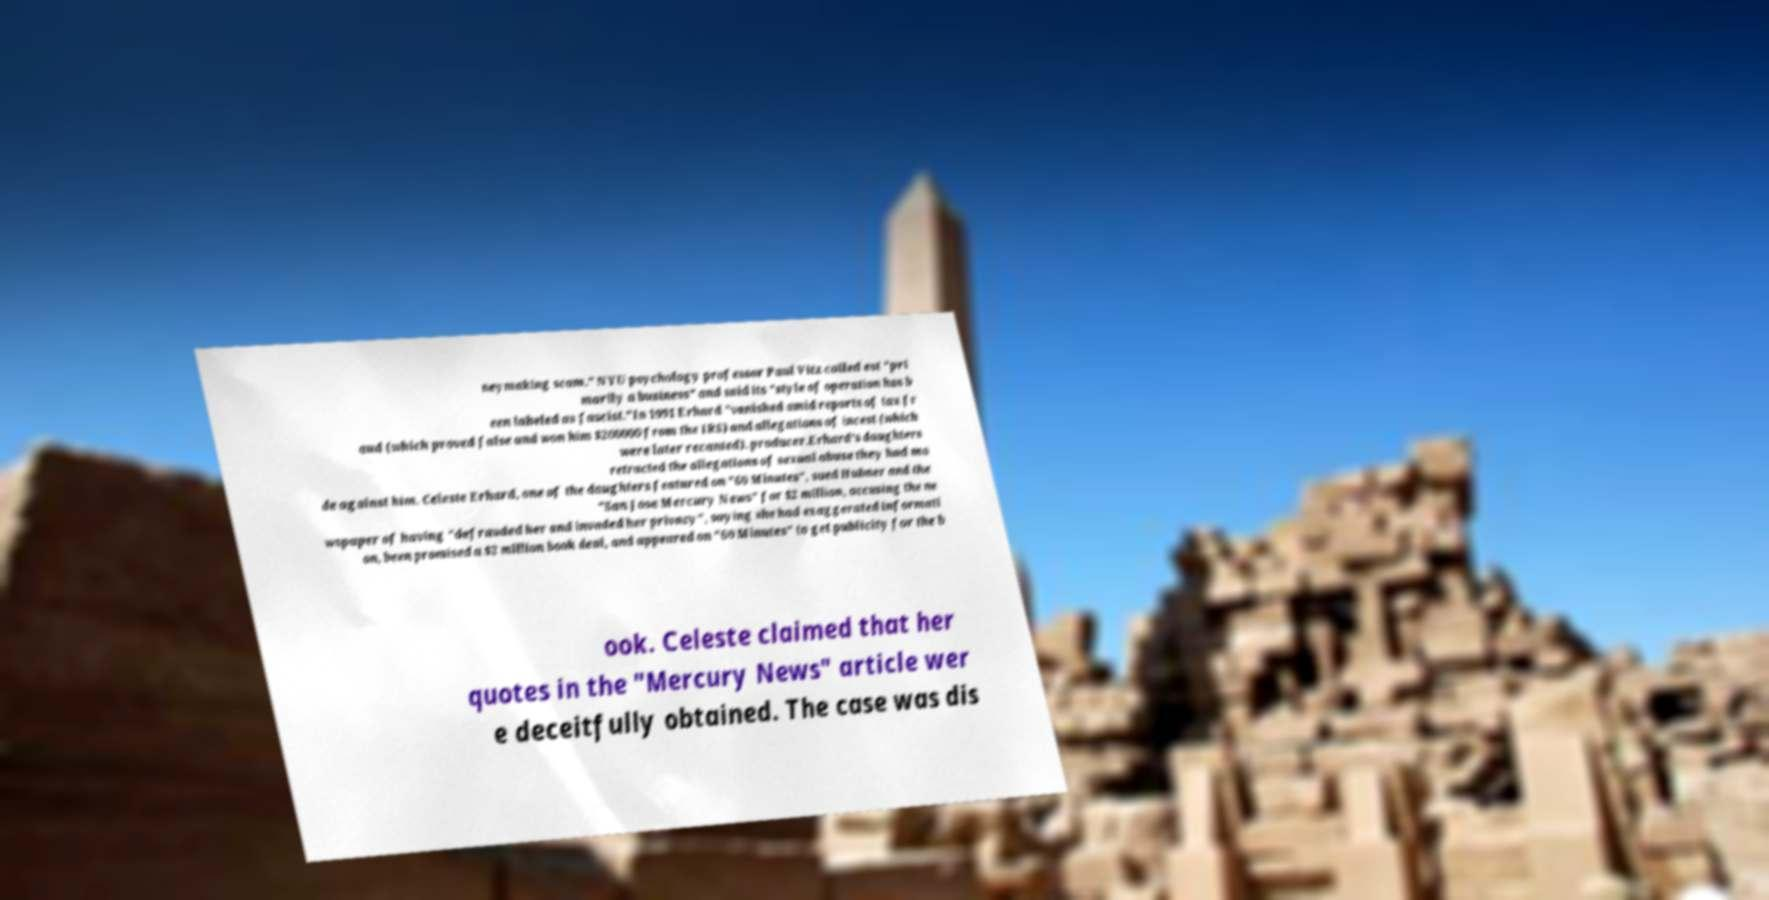Please read and relay the text visible in this image. What does it say? neymaking scam." NYU psychology professor Paul Vitz called est "pri marily a business" and said its "style of operation has b een labeled as fascist."In 1991 Erhard "vanished amid reports of tax fr aud (which proved false and won him $200000 from the IRS) and allegations of incest (which were later recanted). producer.Erhard's daughters retracted the allegations of sexual abuse they had ma de against him. Celeste Erhard, one of the daughters featured on "60 Minutes", sued Hubner and the "San Jose Mercury News" for $2 million, accusing the ne wspaper of having "defrauded her and invaded her privacy", saying she had exaggerated informati on, been promised a $2 million book deal, and appeared on "60 Minutes" to get publicity for the b ook. Celeste claimed that her quotes in the "Mercury News" article wer e deceitfully obtained. The case was dis 